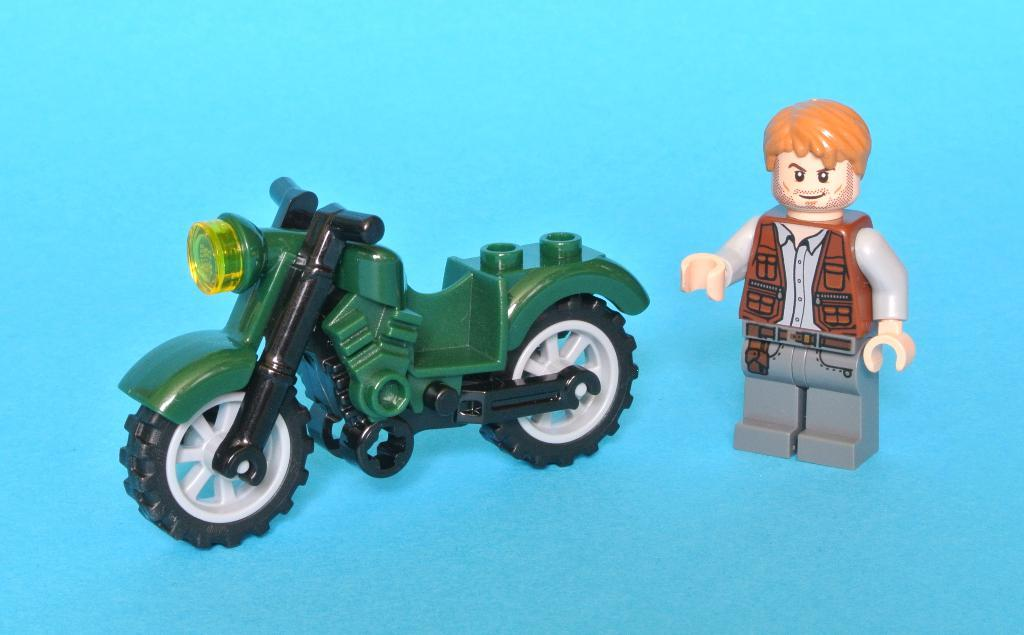How many toys can be seen in the image? There are two toys in the image. What can be observed about the background of the image? The background of the image is blue. Is there a veil covering one of the toys in the image? No, there is no veil present in the image. What type of leg is visible in the image? There are no legs visible in the image; it features two toys and a blue background. 